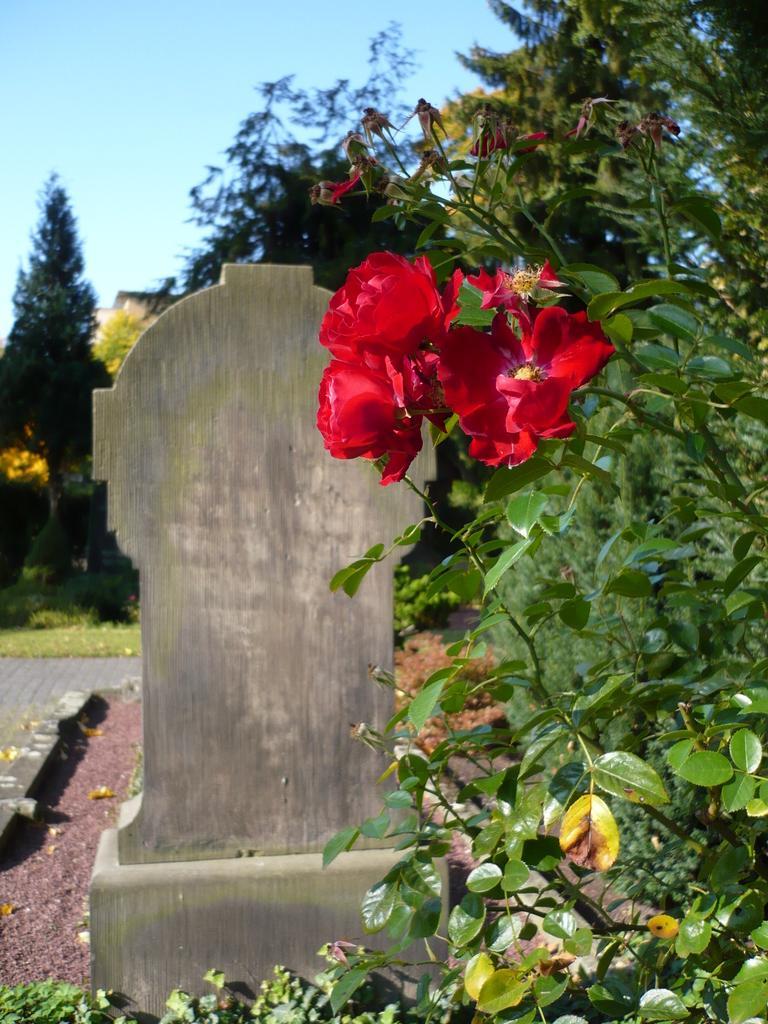Describe this image in one or two sentences. This picture is clicked outside. On the right we can see the flowers and the leaves of the plants. In the center we can see an object. In the background we can see the sky, trees, green grass and some other objects. 